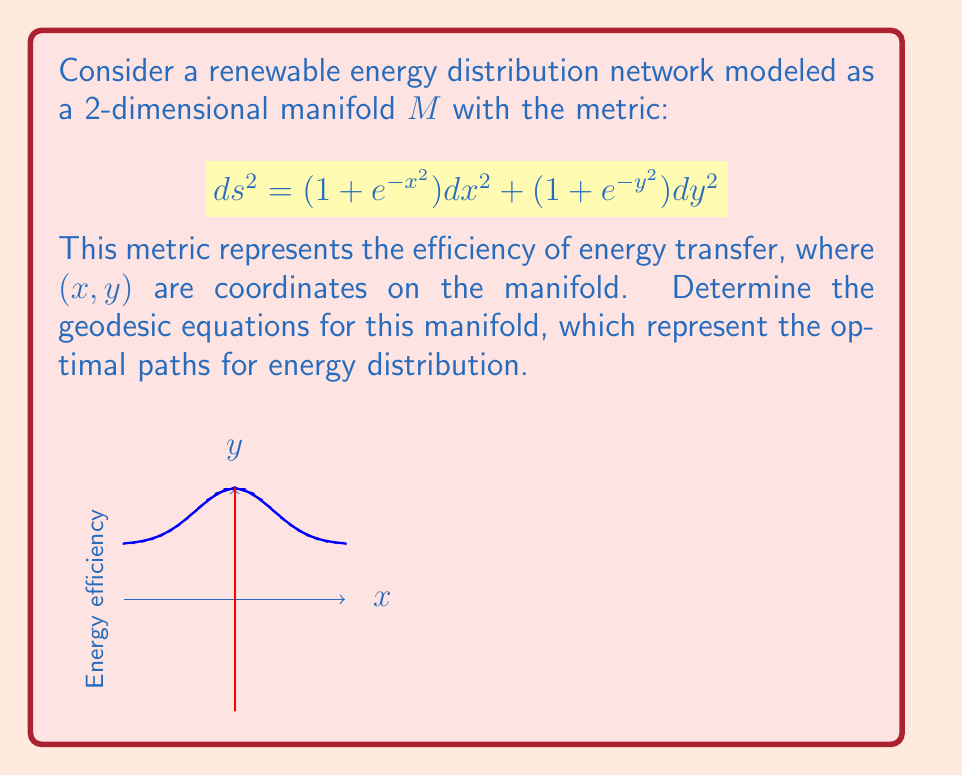Can you answer this question? To find the geodesic equations, we'll follow these steps:

1) First, we need to identify the metric components:
   $g_{11} = 1 + e^{-x^2}$, $g_{22} = 1 + e^{-y^2}$, $g_{12} = g_{21} = 0$

2) Calculate the Christoffel symbols using the formula:
   $$\Gamma^k_{ij} = \frac{1}{2}g^{kl}(\partial_i g_{jl} + \partial_j g_{il} - \partial_l g_{ij})$$

3) For this metric, we need to calculate:
   $\Gamma^1_{11}$, $\Gamma^1_{22}$, $\Gamma^2_{12} = \Gamma^2_{21}$, $\Gamma^2_{22}$

4) Calculating each:
   $\Gamma^1_{11} = \frac{-xe^{-x^2}}{1+e^{-x^2}}$
   $\Gamma^1_{22} = 0$
   $\Gamma^2_{12} = \Gamma^2_{21} = 0$
   $\Gamma^2_{22} = \frac{-ye^{-y^2}}{1+e^{-y^2}}$

5) The geodesic equations are:
   $$\frac{d^2x^i}{dt^2} + \Gamma^i_{jk}\frac{dx^j}{dt}\frac{dx^k}{dt} = 0$$

6) Substituting our Christoffel symbols:
   $$\frac{d^2x}{dt^2} - \frac{xe^{-x^2}}{1+e^{-x^2}}\left(\frac{dx}{dt}\right)^2 = 0$$
   $$\frac{d^2y}{dt^2} - \frac{ye^{-y^2}}{1+e^{-y^2}}\left(\frac{dy}{dt}\right)^2 = 0$$

These are the geodesic equations for our manifold.
Answer: $$\frac{d^2x}{dt^2} - \frac{xe^{-x^2}}{1+e^{-x^2}}\left(\frac{dx}{dt}\right)^2 = 0,\quad \frac{d^2y}{dt^2} - \frac{ye^{-y^2}}{1+e^{-y^2}}\left(\frac{dy}{dt}\right)^2 = 0$$ 